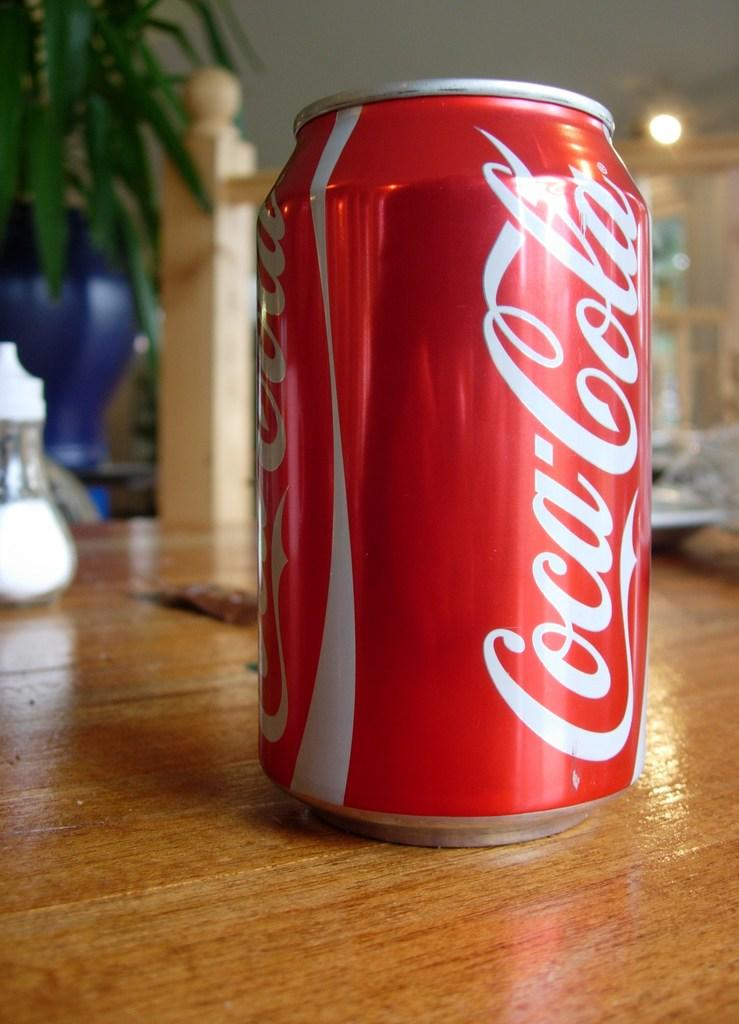<image>
Provide a brief description of the given image. A red can of Coca Cola sitting on a table. 